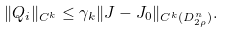Convert formula to latex. <formula><loc_0><loc_0><loc_500><loc_500>\| Q _ { i } \| _ { C ^ { k } } \leq \gamma _ { k } \| J - J _ { 0 } \| _ { C ^ { k } ( D _ { 2 \rho } ^ { n } ) } .</formula> 